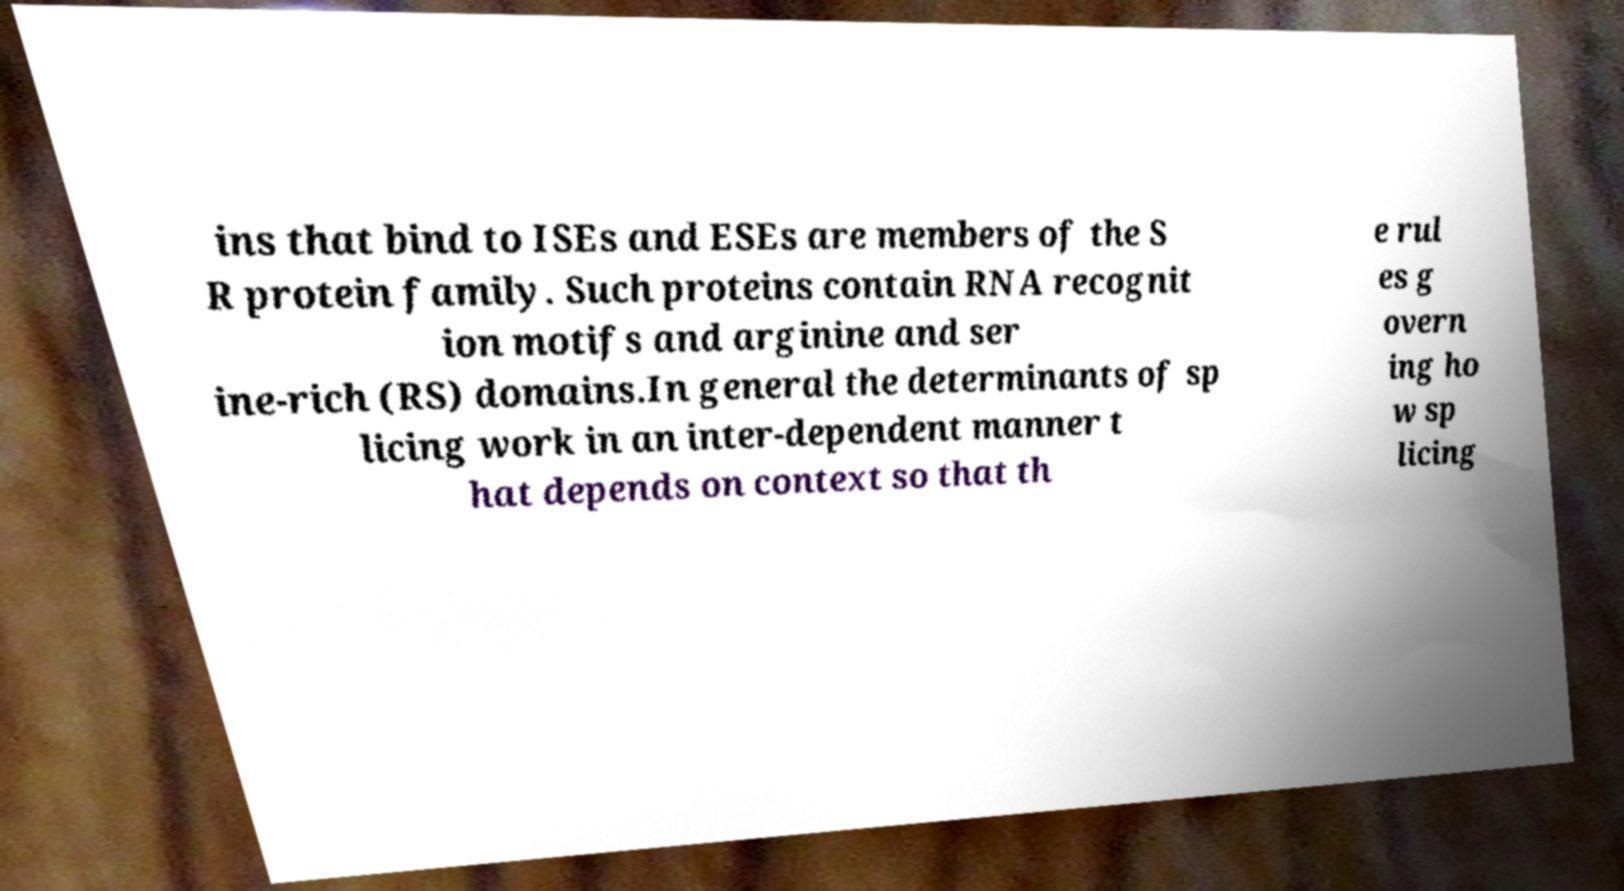Could you assist in decoding the text presented in this image and type it out clearly? ins that bind to ISEs and ESEs are members of the S R protein family. Such proteins contain RNA recognit ion motifs and arginine and ser ine-rich (RS) domains.In general the determinants of sp licing work in an inter-dependent manner t hat depends on context so that th e rul es g overn ing ho w sp licing 